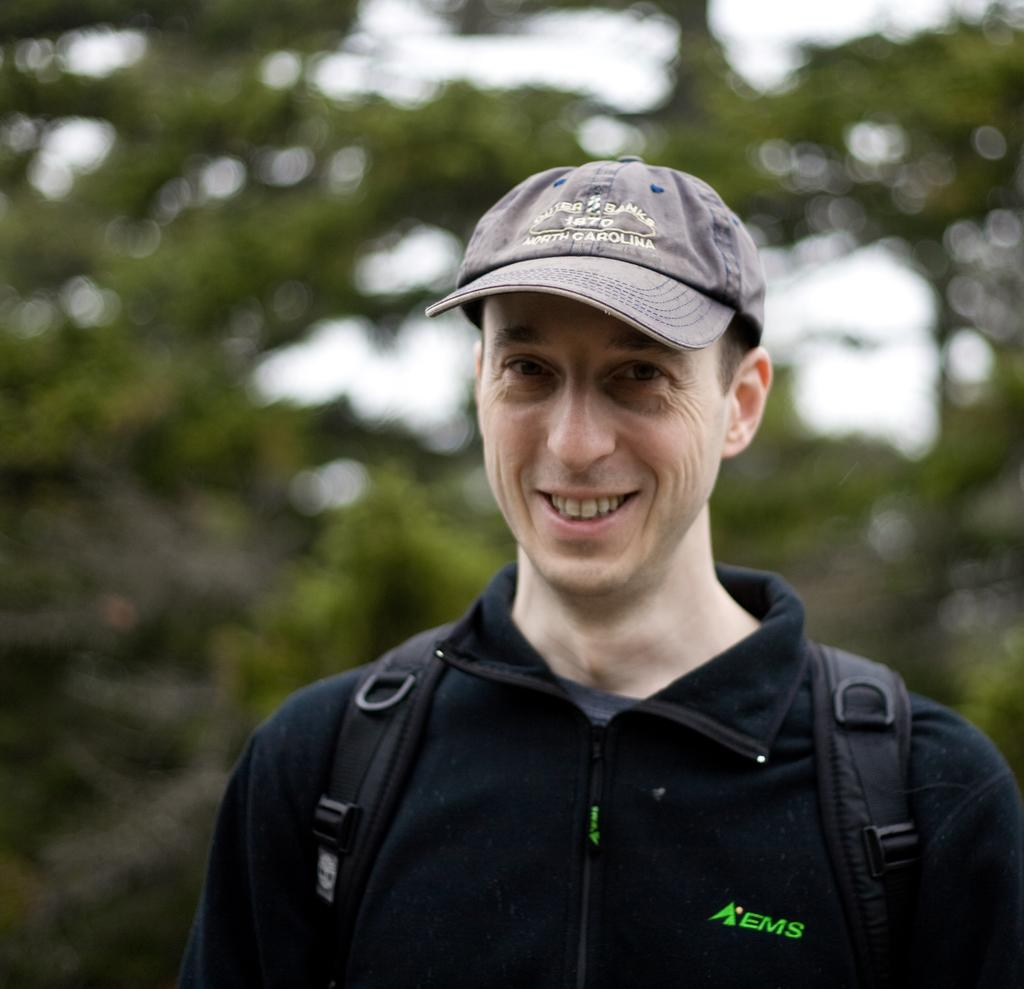What is the main subject of the image? There is a person in the image. What is the person wearing on their upper body? The person is wearing a black t-shirt. What is the person carrying on their body? The person is wearing a bag. What is on the person's head? The person is wearing a cap. What is the person's facial expression? The person is smiling. What is the person's posture in the image? The person is standing. Can you describe the background of the image? The background of the image is blurred. How many rabbits are sitting on the person's shoulders in the image? There are no rabbits present in the image. What type of owl can be seen perched on the person's cap in the image? There is no owl present in the image. 